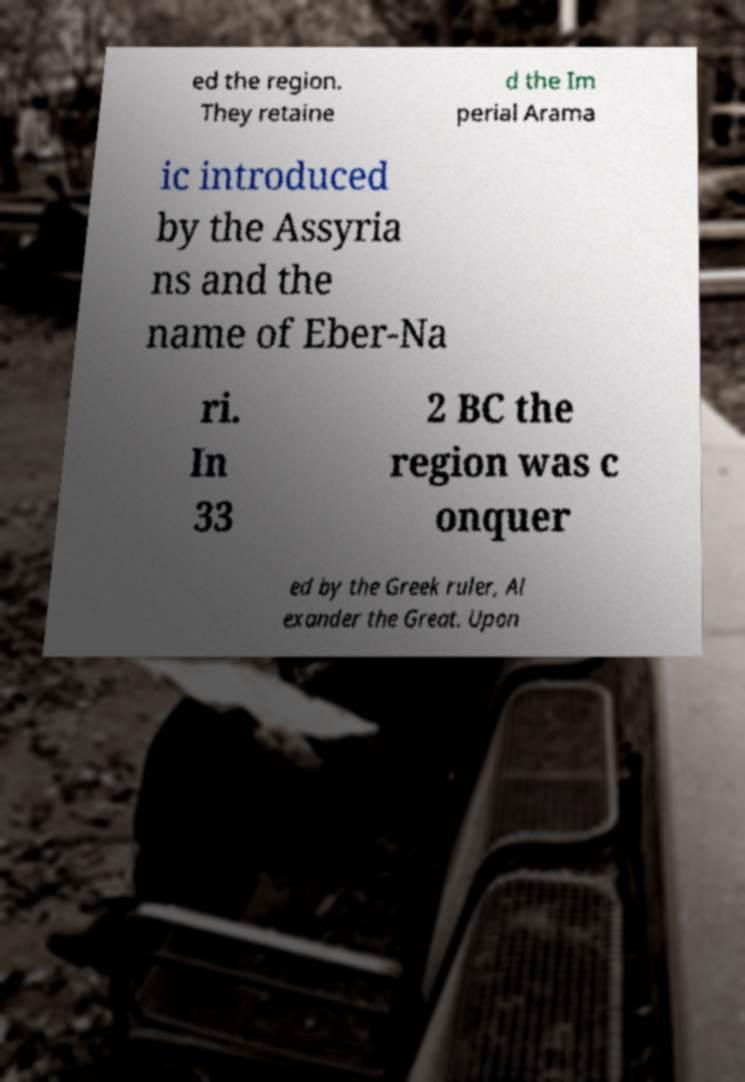For documentation purposes, I need the text within this image transcribed. Could you provide that? ed the region. They retaine d the Im perial Arama ic introduced by the Assyria ns and the name of Eber-Na ri. In 33 2 BC the region was c onquer ed by the Greek ruler, Al exander the Great. Upon 